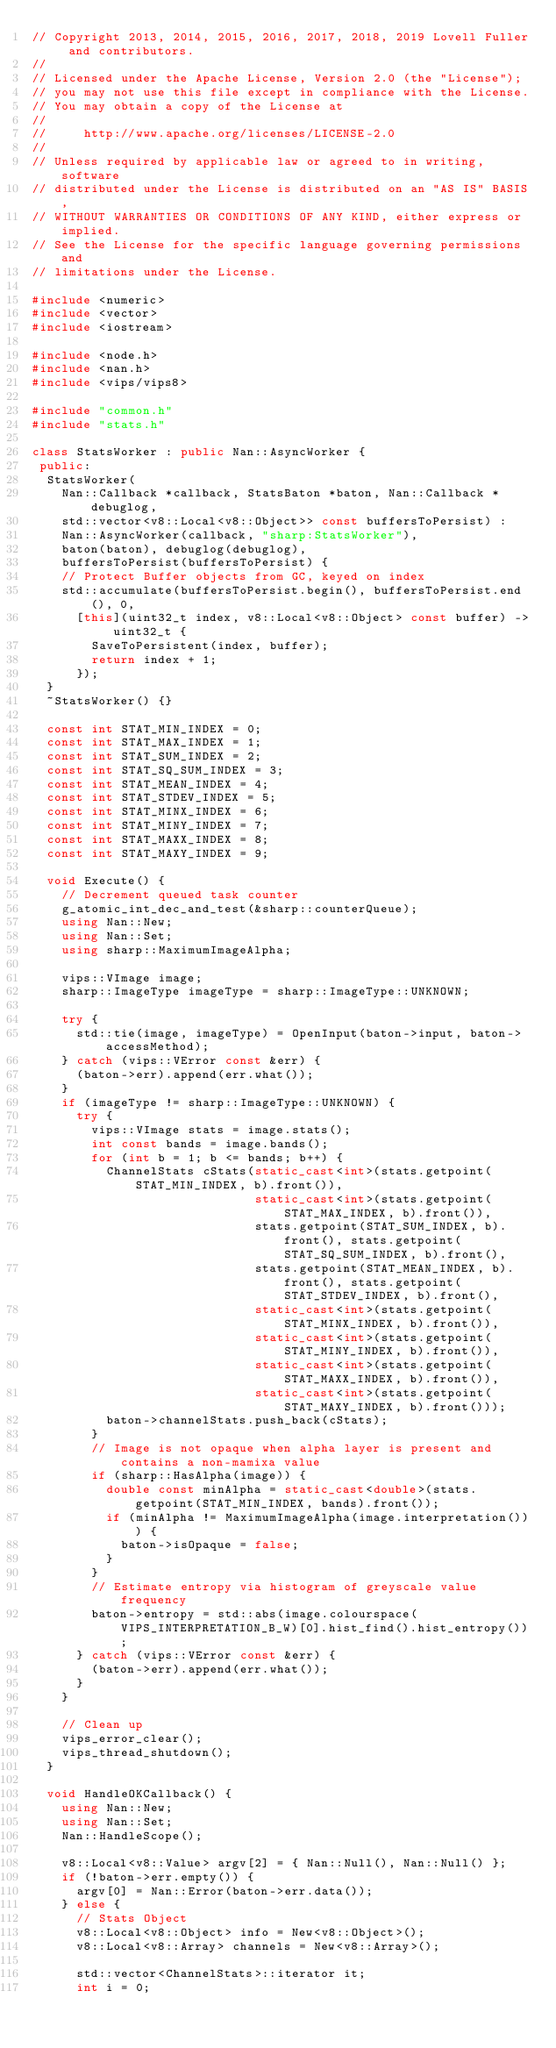<code> <loc_0><loc_0><loc_500><loc_500><_C++_>// Copyright 2013, 2014, 2015, 2016, 2017, 2018, 2019 Lovell Fuller and contributors.
//
// Licensed under the Apache License, Version 2.0 (the "License");
// you may not use this file except in compliance with the License.
// You may obtain a copy of the License at
//
//     http://www.apache.org/licenses/LICENSE-2.0
//
// Unless required by applicable law or agreed to in writing, software
// distributed under the License is distributed on an "AS IS" BASIS,
// WITHOUT WARRANTIES OR CONDITIONS OF ANY KIND, either express or implied.
// See the License for the specific language governing permissions and
// limitations under the License.

#include <numeric>
#include <vector>
#include <iostream>

#include <node.h>
#include <nan.h>
#include <vips/vips8>

#include "common.h"
#include "stats.h"

class StatsWorker : public Nan::AsyncWorker {
 public:
  StatsWorker(
    Nan::Callback *callback, StatsBaton *baton, Nan::Callback *debuglog,
    std::vector<v8::Local<v8::Object>> const buffersToPersist) :
    Nan::AsyncWorker(callback, "sharp:StatsWorker"),
    baton(baton), debuglog(debuglog),
    buffersToPersist(buffersToPersist) {
    // Protect Buffer objects from GC, keyed on index
    std::accumulate(buffersToPersist.begin(), buffersToPersist.end(), 0,
      [this](uint32_t index, v8::Local<v8::Object> const buffer) -> uint32_t {
        SaveToPersistent(index, buffer);
        return index + 1;
      });
  }
  ~StatsWorker() {}

  const int STAT_MIN_INDEX = 0;
  const int STAT_MAX_INDEX = 1;
  const int STAT_SUM_INDEX = 2;
  const int STAT_SQ_SUM_INDEX = 3;
  const int STAT_MEAN_INDEX = 4;
  const int STAT_STDEV_INDEX = 5;
  const int STAT_MINX_INDEX = 6;
  const int STAT_MINY_INDEX = 7;
  const int STAT_MAXX_INDEX = 8;
  const int STAT_MAXY_INDEX = 9;

  void Execute() {
    // Decrement queued task counter
    g_atomic_int_dec_and_test(&sharp::counterQueue);
    using Nan::New;
    using Nan::Set;
    using sharp::MaximumImageAlpha;

    vips::VImage image;
    sharp::ImageType imageType = sharp::ImageType::UNKNOWN;

    try {
      std::tie(image, imageType) = OpenInput(baton->input, baton->accessMethod);
    } catch (vips::VError const &err) {
      (baton->err).append(err.what());
    }
    if (imageType != sharp::ImageType::UNKNOWN) {
      try {
        vips::VImage stats = image.stats();
        int const bands = image.bands();
        for (int b = 1; b <= bands; b++) {
          ChannelStats cStats(static_cast<int>(stats.getpoint(STAT_MIN_INDEX, b).front()),
                              static_cast<int>(stats.getpoint(STAT_MAX_INDEX, b).front()),
                              stats.getpoint(STAT_SUM_INDEX, b).front(), stats.getpoint(STAT_SQ_SUM_INDEX, b).front(),
                              stats.getpoint(STAT_MEAN_INDEX, b).front(), stats.getpoint(STAT_STDEV_INDEX, b).front(),
                              static_cast<int>(stats.getpoint(STAT_MINX_INDEX, b).front()),
                              static_cast<int>(stats.getpoint(STAT_MINY_INDEX, b).front()),
                              static_cast<int>(stats.getpoint(STAT_MAXX_INDEX, b).front()),
                              static_cast<int>(stats.getpoint(STAT_MAXY_INDEX, b).front()));
          baton->channelStats.push_back(cStats);
        }
        // Image is not opaque when alpha layer is present and contains a non-mamixa value
        if (sharp::HasAlpha(image)) {
          double const minAlpha = static_cast<double>(stats.getpoint(STAT_MIN_INDEX, bands).front());
          if (minAlpha != MaximumImageAlpha(image.interpretation())) {
            baton->isOpaque = false;
          }
        }
        // Estimate entropy via histogram of greyscale value frequency
        baton->entropy = std::abs(image.colourspace(VIPS_INTERPRETATION_B_W)[0].hist_find().hist_entropy());
      } catch (vips::VError const &err) {
        (baton->err).append(err.what());
      }
    }

    // Clean up
    vips_error_clear();
    vips_thread_shutdown();
  }

  void HandleOKCallback() {
    using Nan::New;
    using Nan::Set;
    Nan::HandleScope();

    v8::Local<v8::Value> argv[2] = { Nan::Null(), Nan::Null() };
    if (!baton->err.empty()) {
      argv[0] = Nan::Error(baton->err.data());
    } else {
      // Stats Object
      v8::Local<v8::Object> info = New<v8::Object>();
      v8::Local<v8::Array> channels = New<v8::Array>();

      std::vector<ChannelStats>::iterator it;
      int i = 0;</code> 